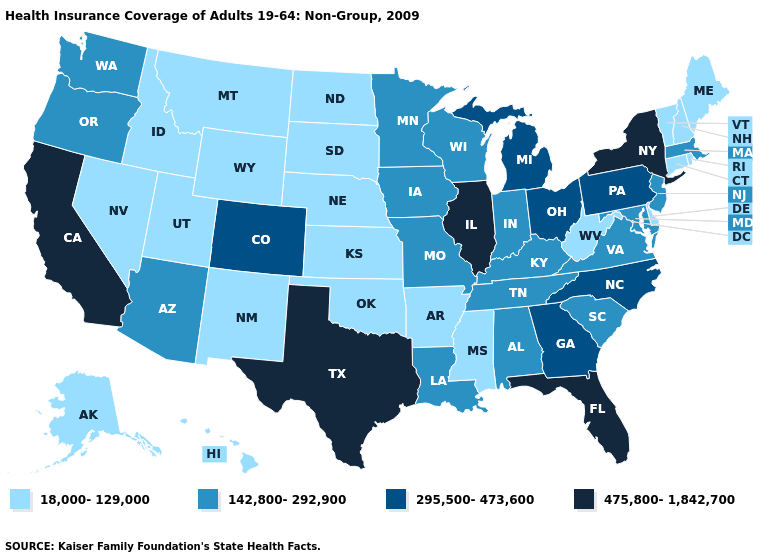Does North Dakota have the same value as California?
Concise answer only. No. Name the states that have a value in the range 475,800-1,842,700?
Keep it brief. California, Florida, Illinois, New York, Texas. What is the value of Delaware?
Answer briefly. 18,000-129,000. What is the lowest value in states that border Nebraska?
Give a very brief answer. 18,000-129,000. Name the states that have a value in the range 18,000-129,000?
Keep it brief. Alaska, Arkansas, Connecticut, Delaware, Hawaii, Idaho, Kansas, Maine, Mississippi, Montana, Nebraska, Nevada, New Hampshire, New Mexico, North Dakota, Oklahoma, Rhode Island, South Dakota, Utah, Vermont, West Virginia, Wyoming. What is the lowest value in the USA?
Concise answer only. 18,000-129,000. Does the map have missing data?
Be succinct. No. Which states have the lowest value in the MidWest?
Short answer required. Kansas, Nebraska, North Dakota, South Dakota. Name the states that have a value in the range 295,500-473,600?
Quick response, please. Colorado, Georgia, Michigan, North Carolina, Ohio, Pennsylvania. Name the states that have a value in the range 475,800-1,842,700?
Write a very short answer. California, Florida, Illinois, New York, Texas. Among the states that border Florida , does Alabama have the lowest value?
Give a very brief answer. Yes. What is the lowest value in the USA?
Quick response, please. 18,000-129,000. What is the value of Iowa?
Short answer required. 142,800-292,900. What is the value of Connecticut?
Answer briefly. 18,000-129,000. Name the states that have a value in the range 475,800-1,842,700?
Keep it brief. California, Florida, Illinois, New York, Texas. 